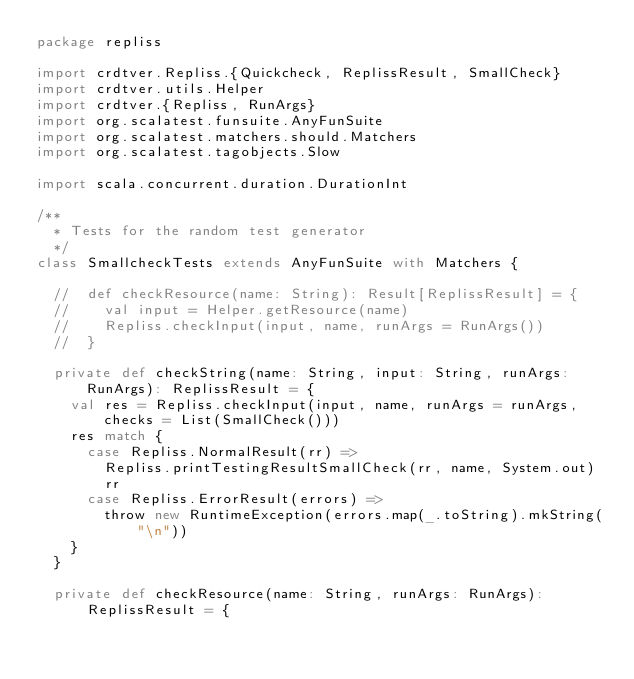Convert code to text. <code><loc_0><loc_0><loc_500><loc_500><_Scala_>package repliss

import crdtver.Repliss.{Quickcheck, ReplissResult, SmallCheck}
import crdtver.utils.Helper
import crdtver.{Repliss, RunArgs}
import org.scalatest.funsuite.AnyFunSuite
import org.scalatest.matchers.should.Matchers
import org.scalatest.tagobjects.Slow

import scala.concurrent.duration.DurationInt

/**
  * Tests for the random test generator
  */
class SmallcheckTests extends AnyFunSuite with Matchers {

  //  def checkResource(name: String): Result[ReplissResult] = {
  //    val input = Helper.getResource(name)
  //    Repliss.checkInput(input, name, runArgs = RunArgs())
  //  }

  private def checkString(name: String, input: String, runArgs: RunArgs): ReplissResult = {
    val res = Repliss.checkInput(input, name, runArgs = runArgs, checks = List(SmallCheck()))
    res match {
      case Repliss.NormalResult(rr) =>
        Repliss.printTestingResultSmallCheck(rr, name, System.out)
        rr
      case Repliss.ErrorResult(errors) =>
        throw new RuntimeException(errors.map(_.toString).mkString("\n"))
    }
  }

  private def checkResource(name: String, runArgs: RunArgs): ReplissResult = {</code> 